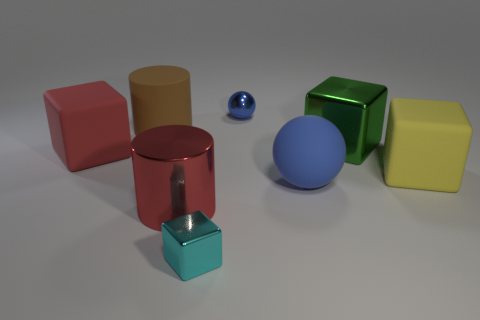What number of red things are large matte objects or large rubber cylinders?
Make the answer very short. 1. What color is the big metal cylinder?
Make the answer very short. Red. There is a cyan block that is the same material as the red cylinder; what size is it?
Provide a short and direct response. Small. What number of other tiny metal things have the same shape as the tiny cyan thing?
Keep it short and to the point. 0. There is a metallic cube in front of the large matte thing to the right of the green cube; what is its size?
Offer a very short reply. Small. What is the material of the ball that is the same size as the cyan metal cube?
Offer a terse response. Metal. Are there any big spheres made of the same material as the large green thing?
Make the answer very short. No. There is a shiny cube in front of the large rubber block left of the large red thing in front of the red rubber cube; what color is it?
Your answer should be very brief. Cyan. There is a tiny shiny thing that is behind the big green metallic cube; does it have the same color as the ball that is in front of the large brown object?
Keep it short and to the point. Yes. Is there any other thing of the same color as the small cube?
Offer a terse response. No. 